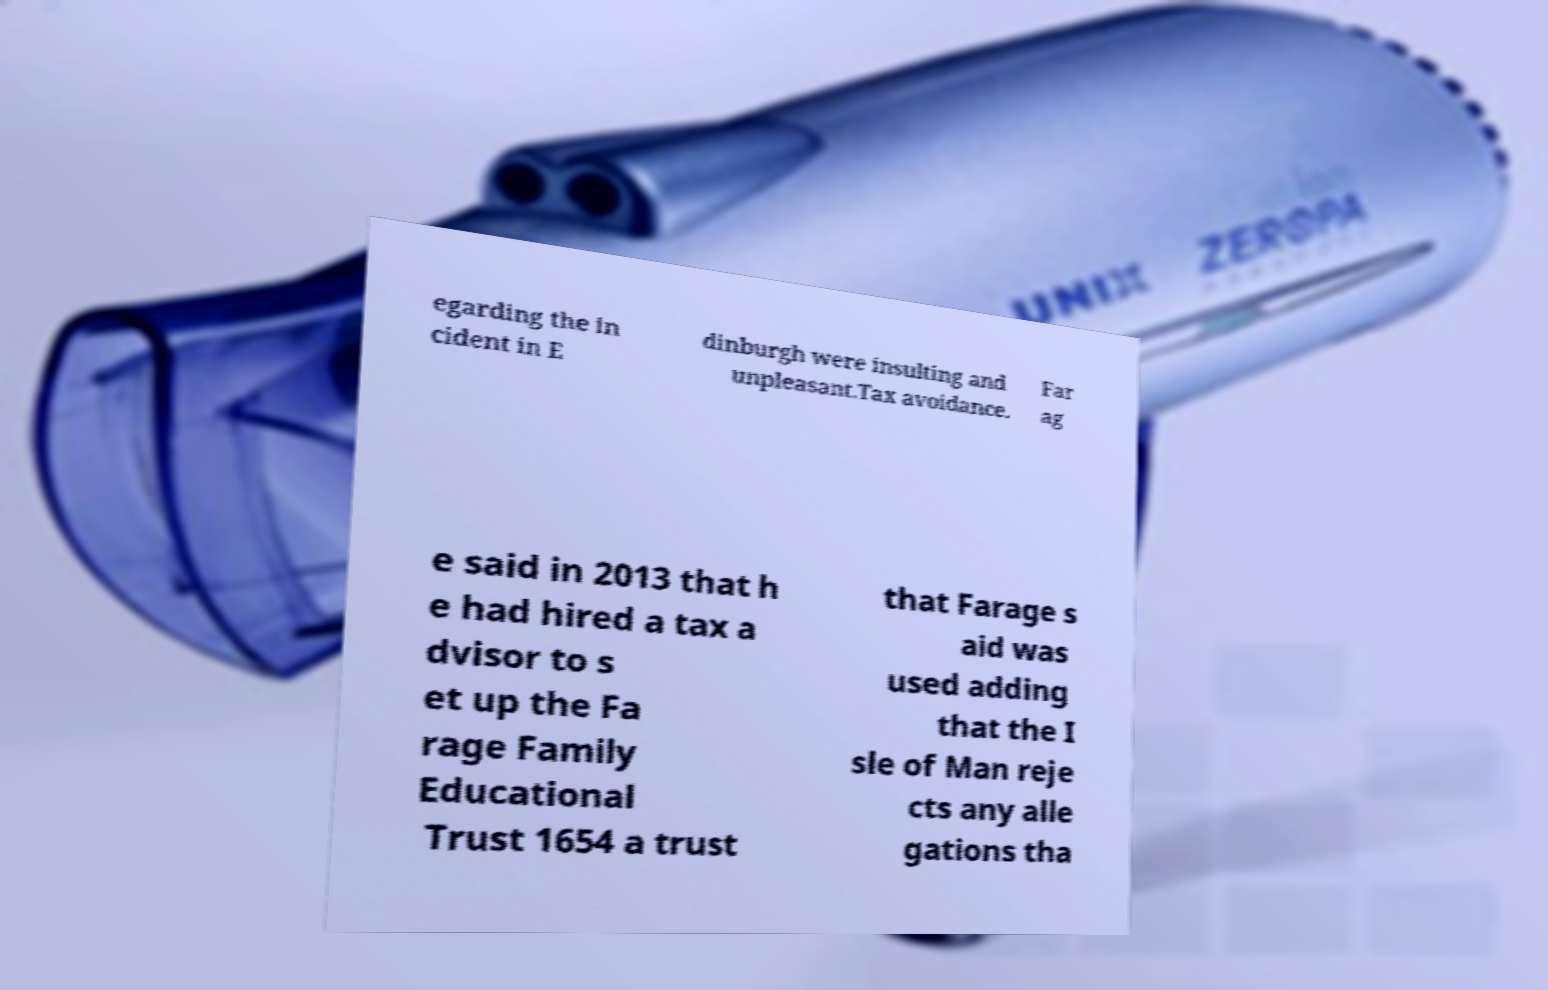Could you assist in decoding the text presented in this image and type it out clearly? egarding the in cident in E dinburgh were insulting and unpleasant.Tax avoidance. Far ag e said in 2013 that h e had hired a tax a dvisor to s et up the Fa rage Family Educational Trust 1654 a trust that Farage s aid was used adding that the I sle of Man reje cts any alle gations tha 